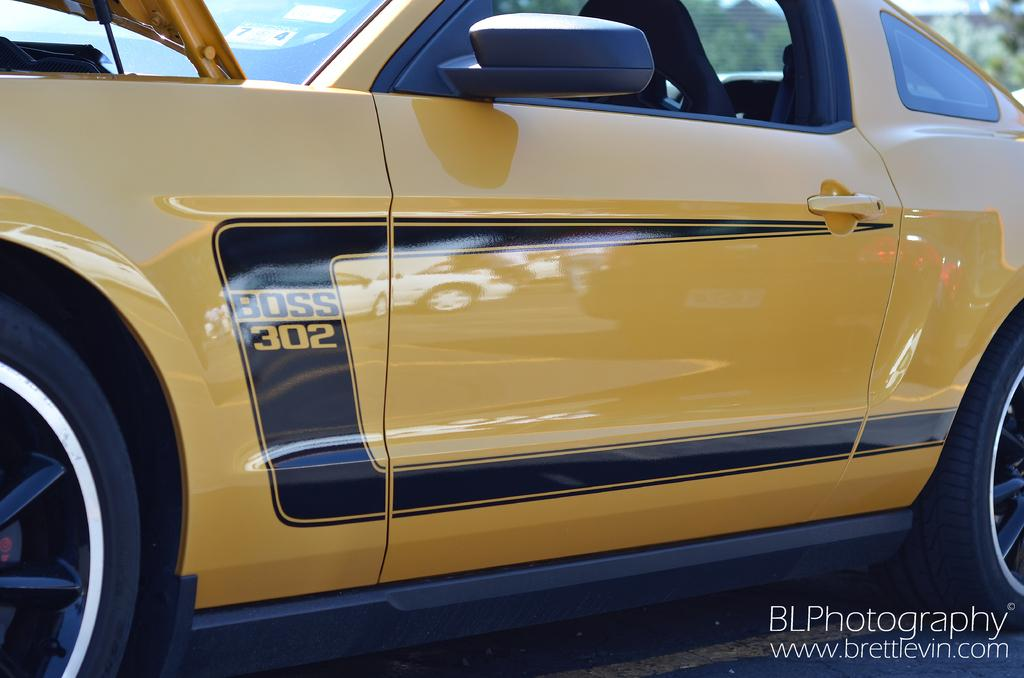What is the main subject of the image? The main subject of the image is a car on the road. What can be seen in the top right corner of the image? There is a building and trees visible in the top right corner of the image. Is there any text or marking in the image? Yes, there is a watermark in the bottom right corner of the image. What type of event is happening in the image? There is no event happening in the image; it is a static scene featuring a car on the road, a building, trees, and a watermark. Can you see a jail in the image? No, there is no jail present in the image. 